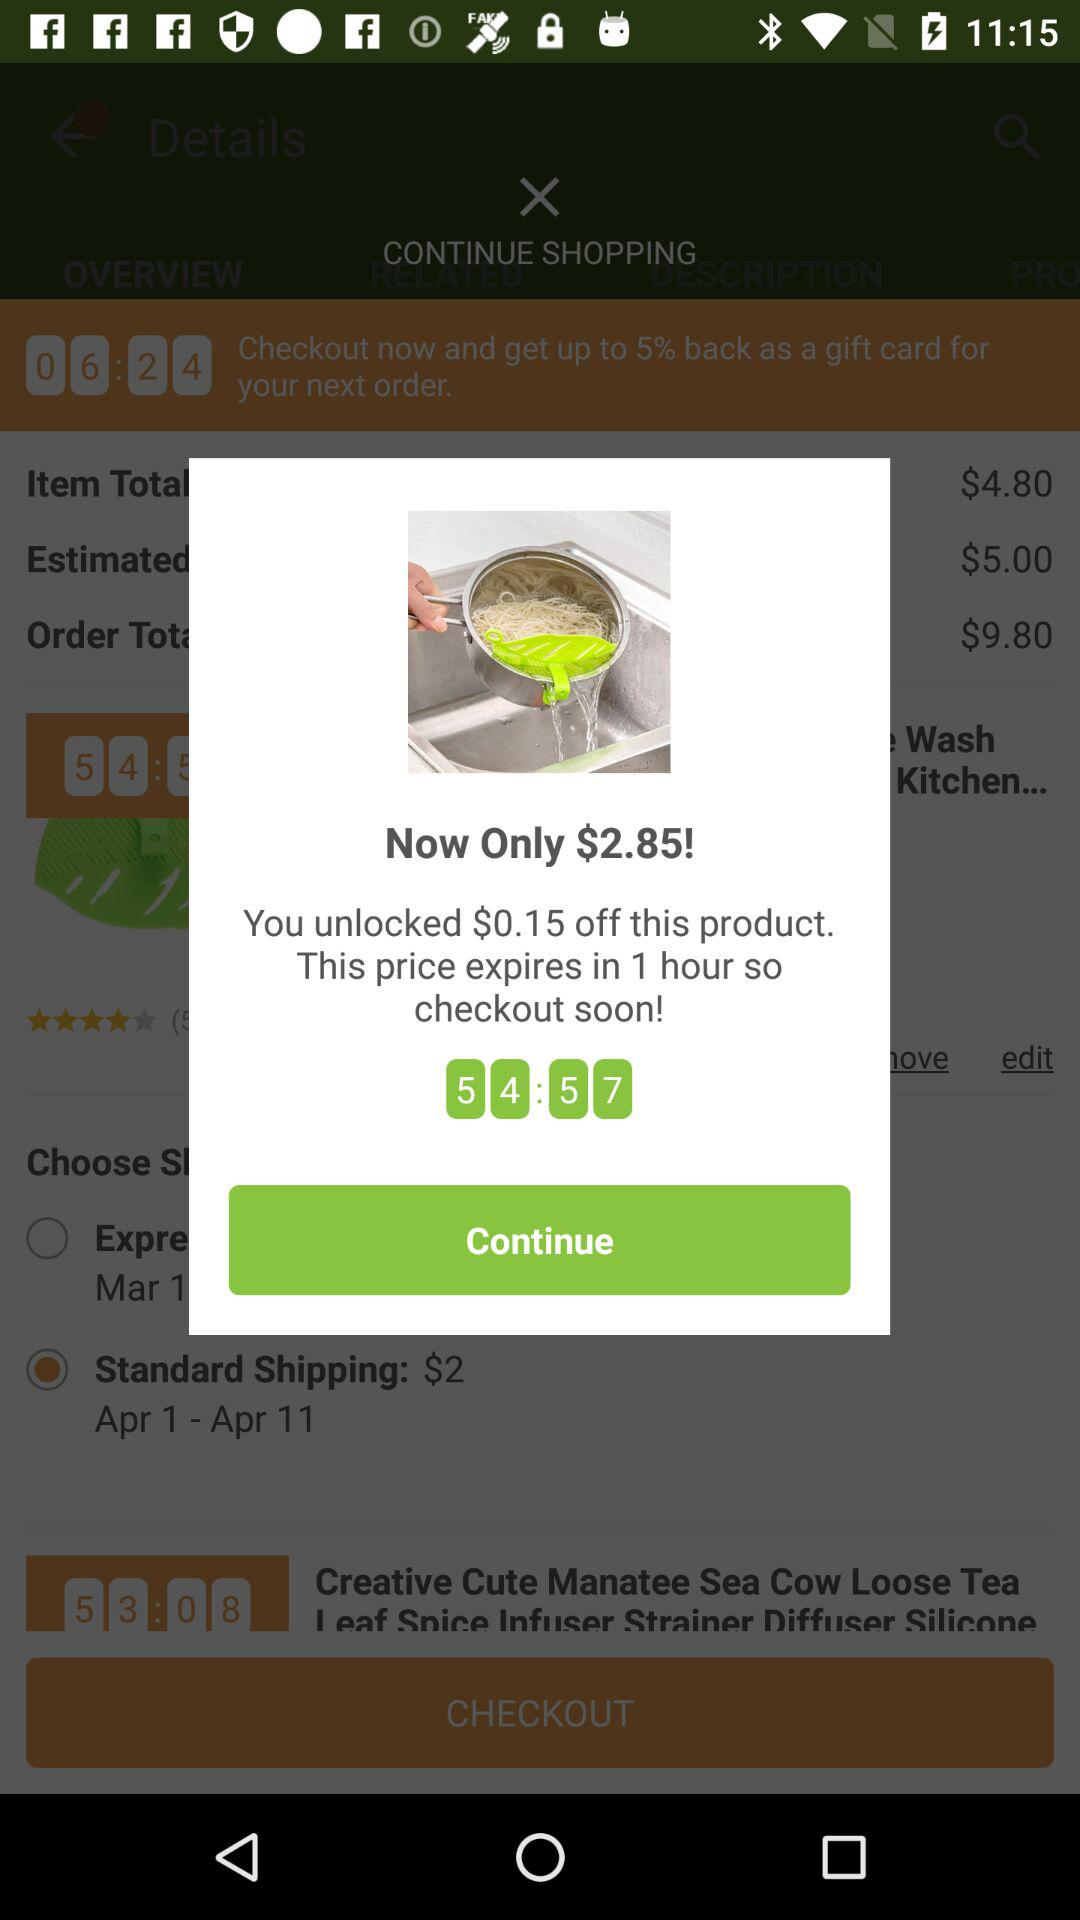How much time is left to avail the offer price? The time left to avail the offer price is 54 minutes 57 seconds. 